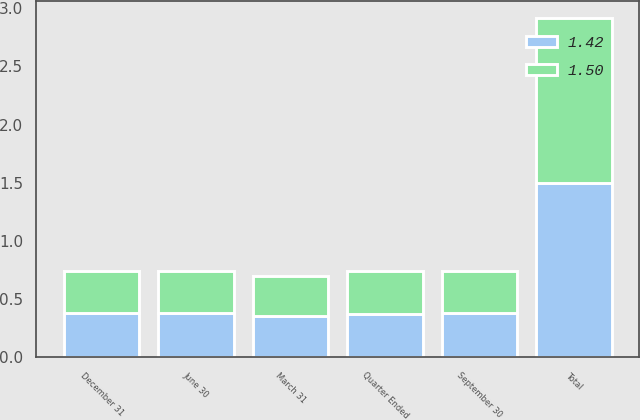Convert chart to OTSL. <chart><loc_0><loc_0><loc_500><loc_500><stacked_bar_chart><ecel><fcel>Quarter Ended<fcel>March 31<fcel>June 30<fcel>September 30<fcel>December 31<fcel>Total<nl><fcel>1.42<fcel>0.37<fcel>0.36<fcel>0.38<fcel>0.38<fcel>0.38<fcel>1.5<nl><fcel>1.5<fcel>0.37<fcel>0.34<fcel>0.36<fcel>0.36<fcel>0.36<fcel>1.42<nl></chart> 